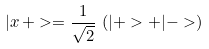<formula> <loc_0><loc_0><loc_500><loc_500>| x \, + > = \frac { 1 } { \sqrt { 2 } } \, \left ( | + > + | - > \right )</formula> 